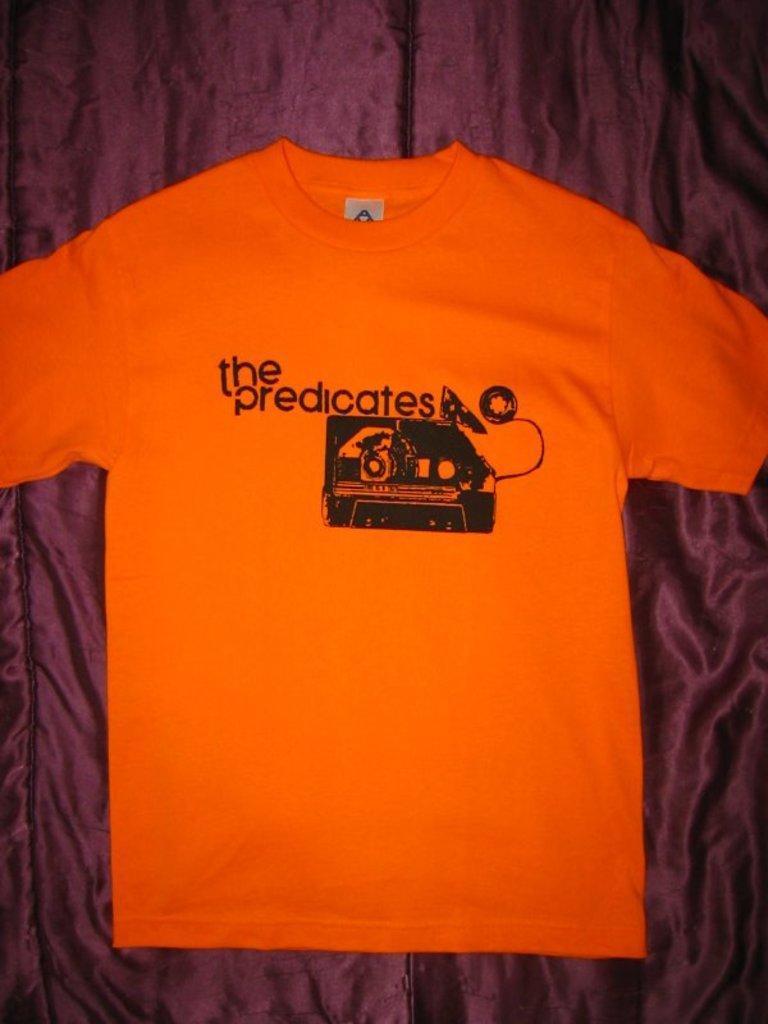Can you describe this image briefly? In this image I can see the shirt in orange color and I can see the brown color background. 